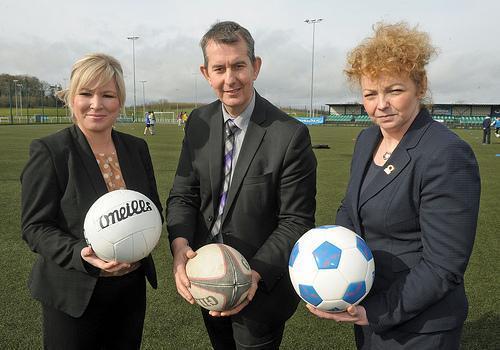How many people are wearing a tie in the picture?
Give a very brief answer. 1. 